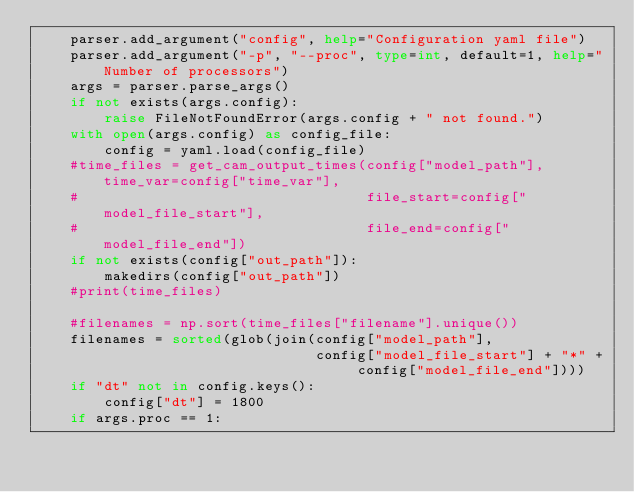Convert code to text. <code><loc_0><loc_0><loc_500><loc_500><_Python_>    parser.add_argument("config", help="Configuration yaml file")
    parser.add_argument("-p", "--proc", type=int, default=1, help="Number of processors")
    args = parser.parse_args()
    if not exists(args.config):
        raise FileNotFoundError(args.config + " not found.")
    with open(args.config) as config_file:
        config = yaml.load(config_file)
    #time_files = get_cam_output_times(config["model_path"], time_var=config["time_var"],
    #                                  file_start=config["model_file_start"],
    #                                  file_end=config["model_file_end"])
    if not exists(config["out_path"]):
        makedirs(config["out_path"])
    #print(time_files)

    #filenames = np.sort(time_files["filename"].unique())
    filenames = sorted(glob(join(config["model_path"],
                                 config["model_file_start"] + "*" + config["model_file_end"])))
    if "dt" not in config.keys():
        config["dt"] = 1800
    if args.proc == 1:</code> 